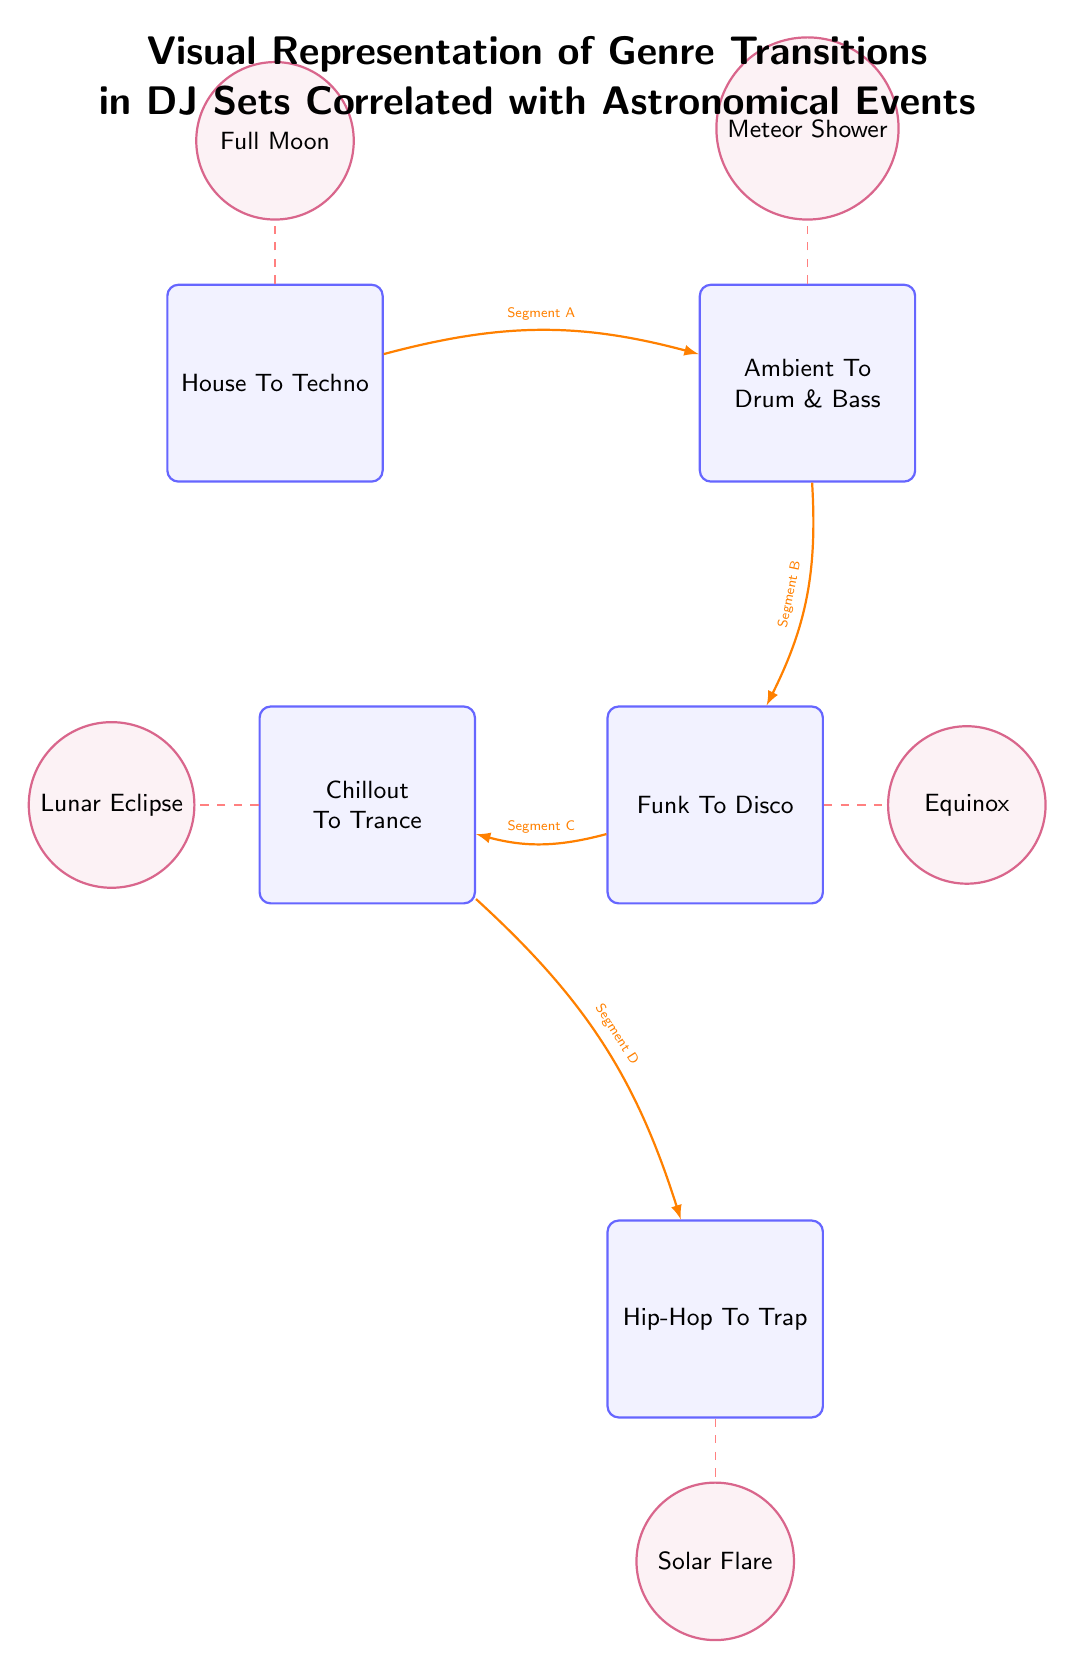What are the genres transitioning from House? The diagram indicates that the genre transitioning from House is Techno, as it is directly connected with an edge from House to Techno.
Answer: Techno How many transitions are represented in the diagram? The diagram shows five transitions labeled as House to Techno, Ambient to Drum & Bass, Funk to Disco, Chillout to Trance, and Hip-Hop to Trap. Therefore, there are five transitions represented.
Answer: 5 Which astronomical event corresponds with Hip-Hop to Trap? The dashed line connects the Hip-Hop to Trap transition with the Solar Flare astronomical event, indicating the correlation between them.
Answer: Solar Flare What is the last transition in the sequence? By following the edges from top to bottom in the diagram, the last transition that appears is Hip-Hop to Trap.
Answer: Hip-Hop To Trap Which transition is related to the Full Moon? The Full Moon is connected to the House to Techno transition through a dashed line, establishing its correlation in this diagram.
Answer: House To Techno What is the order of transitions from Full Moon downwards? Starting from the Full Moon, the transitions progress from House to Techno, then Ambient to Drum & Bass, followed by Funk to Disco, Chillout to Trance, and finally ending at Hip-Hop to Trap.
Answer: House To Techno, Ambient To Drum & Bass, Funk To Disco, Chillout To Trance, Hip-Hop To Trap Which two transitions are correlated with the Lunar Eclipse? The diagram shows that Chillout to Trance is the only transition related to the Lunar Eclipse, as indicated by the dashed line connecting them. No other transition connects to the Lunar Eclipse.
Answer: Chillout To Trance How do the transitions relate to the Meteor Shower? The transition from Ambient to Drum & Bass is specifically linked to the Meteor Shower event, as per the arrow connecting them in the diagram.
Answer: Ambient To Drum & Bass What color are the transition nodes? All the transition nodes in the diagram are filled with a light blue color, making them visually distinct from other elements.
Answer: Light Blue 